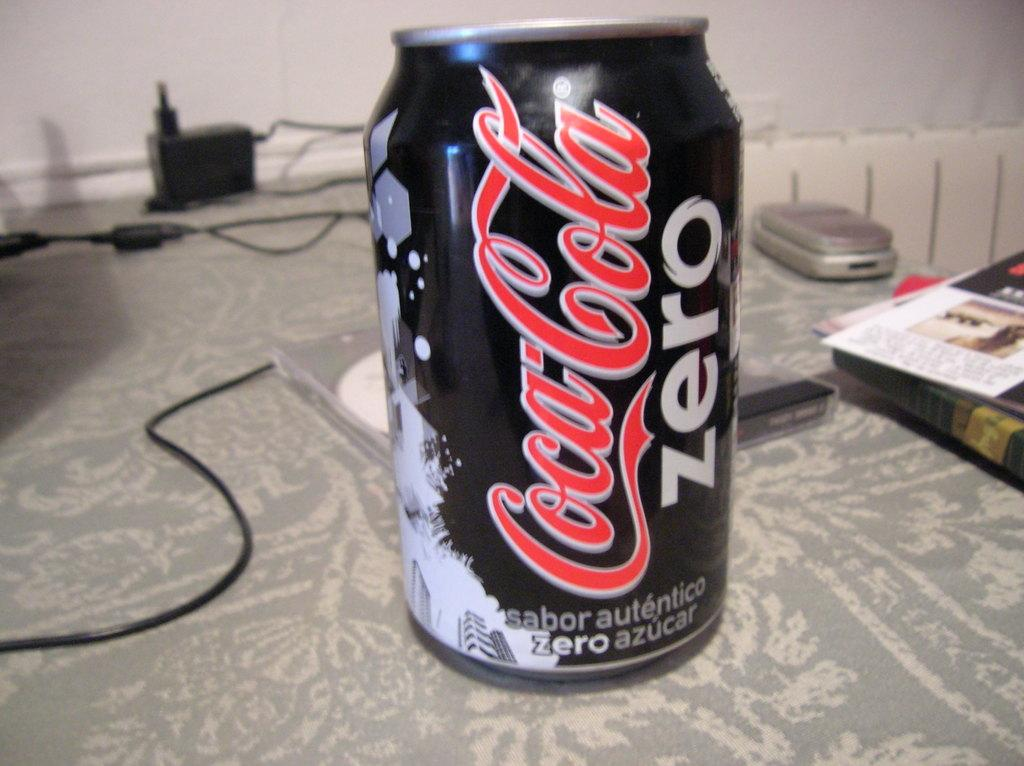<image>
Describe the image concisely. The drink shown here is a Coca-Cola Zero 